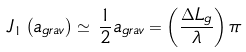Convert formula to latex. <formula><loc_0><loc_0><loc_500><loc_500>J _ { 1 } \left ( a _ { g r a v } \right ) \simeq \, \frac { 1 } { 2 } a _ { g r a v } = \left ( \frac { \Delta L _ { g } } { \lambda } \right ) \pi</formula> 